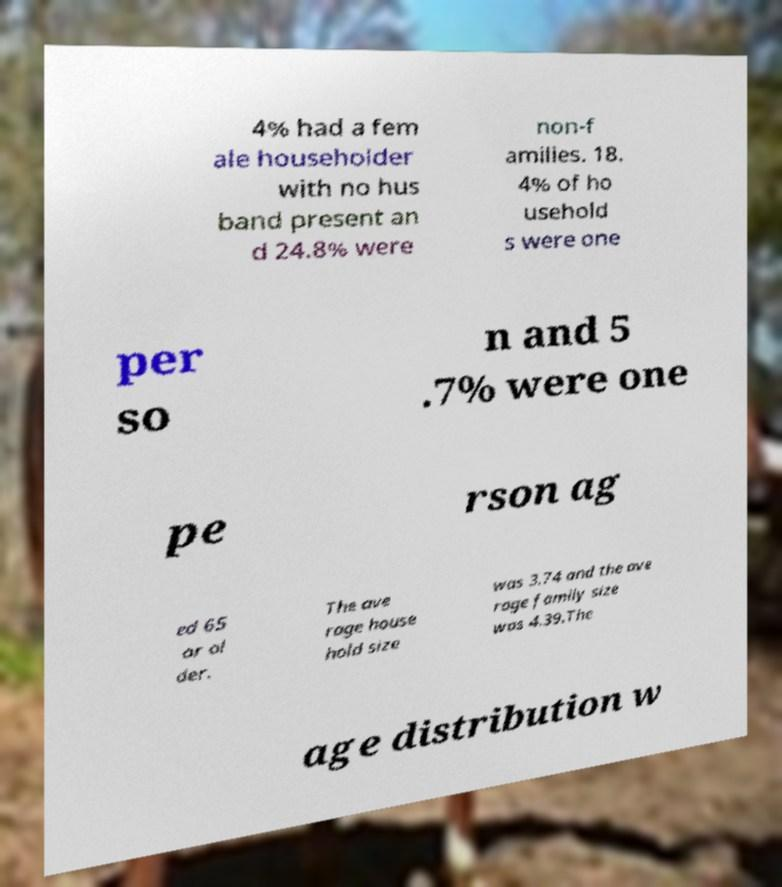For documentation purposes, I need the text within this image transcribed. Could you provide that? 4% had a fem ale householder with no hus band present an d 24.8% were non-f amilies. 18. 4% of ho usehold s were one per so n and 5 .7% were one pe rson ag ed 65 or ol der. The ave rage house hold size was 3.74 and the ave rage family size was 4.39.The age distribution w 